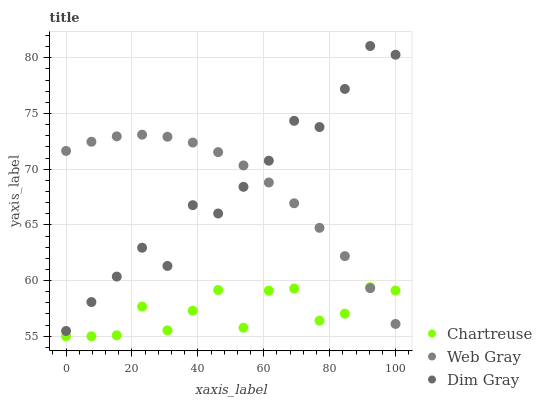Does Chartreuse have the minimum area under the curve?
Answer yes or no. Yes. Does Web Gray have the maximum area under the curve?
Answer yes or no. Yes. Does Dim Gray have the minimum area under the curve?
Answer yes or no. No. Does Dim Gray have the maximum area under the curve?
Answer yes or no. No. Is Web Gray the smoothest?
Answer yes or no. Yes. Is Chartreuse the roughest?
Answer yes or no. Yes. Is Dim Gray the smoothest?
Answer yes or no. No. Is Dim Gray the roughest?
Answer yes or no. No. Does Chartreuse have the lowest value?
Answer yes or no. Yes. Does Dim Gray have the lowest value?
Answer yes or no. No. Does Dim Gray have the highest value?
Answer yes or no. Yes. Does Web Gray have the highest value?
Answer yes or no. No. Is Chartreuse less than Dim Gray?
Answer yes or no. Yes. Is Dim Gray greater than Chartreuse?
Answer yes or no. Yes. Does Chartreuse intersect Web Gray?
Answer yes or no. Yes. Is Chartreuse less than Web Gray?
Answer yes or no. No. Is Chartreuse greater than Web Gray?
Answer yes or no. No. Does Chartreuse intersect Dim Gray?
Answer yes or no. No. 